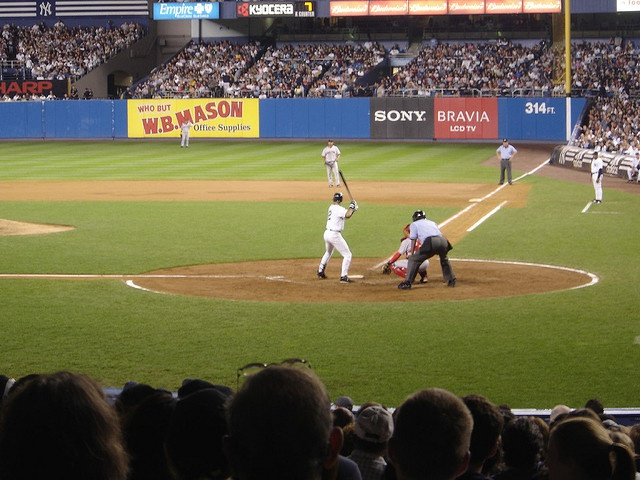Describe the objects in this image and their specific colors. I can see people in navy, black, gray, darkgray, and maroon tones, people in navy, black, and gray tones, people in navy, black, darkgreen, and gray tones, people in navy, black, darkgreen, and gray tones, and people in navy, black, and gray tones in this image. 